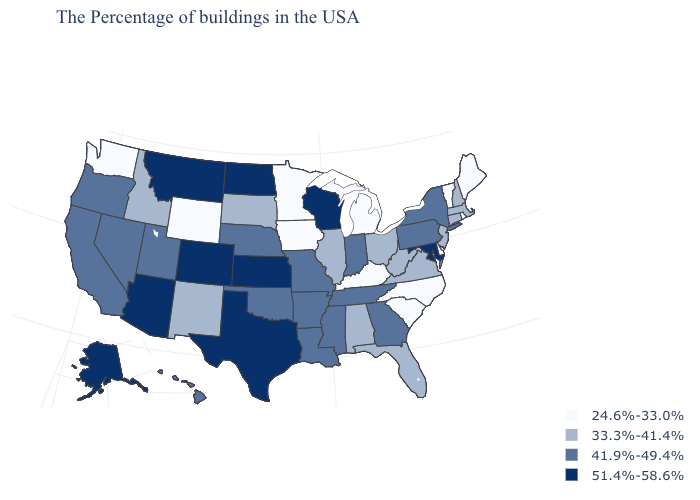Which states hav the highest value in the West?
Write a very short answer. Colorado, Montana, Arizona, Alaska. What is the value of Minnesota?
Answer briefly. 24.6%-33.0%. Does Missouri have a lower value than North Dakota?
Give a very brief answer. Yes. Which states have the highest value in the USA?
Answer briefly. Maryland, Wisconsin, Kansas, Texas, North Dakota, Colorado, Montana, Arizona, Alaska. Does Massachusetts have the lowest value in the Northeast?
Quick response, please. No. Does Vermont have the lowest value in the Northeast?
Short answer required. Yes. What is the value of Wisconsin?
Keep it brief. 51.4%-58.6%. Among the states that border Michigan , does Wisconsin have the highest value?
Keep it brief. Yes. What is the value of Kentucky?
Give a very brief answer. 24.6%-33.0%. What is the value of Alaska?
Quick response, please. 51.4%-58.6%. Name the states that have a value in the range 24.6%-33.0%?
Be succinct. Maine, Rhode Island, Vermont, Delaware, North Carolina, South Carolina, Michigan, Kentucky, Minnesota, Iowa, Wyoming, Washington. Does Texas have the highest value in the USA?
Keep it brief. Yes. Does Connecticut have the lowest value in the USA?
Keep it brief. No. Name the states that have a value in the range 41.9%-49.4%?
Concise answer only. New York, Pennsylvania, Georgia, Indiana, Tennessee, Mississippi, Louisiana, Missouri, Arkansas, Nebraska, Oklahoma, Utah, Nevada, California, Oregon, Hawaii. Name the states that have a value in the range 41.9%-49.4%?
Be succinct. New York, Pennsylvania, Georgia, Indiana, Tennessee, Mississippi, Louisiana, Missouri, Arkansas, Nebraska, Oklahoma, Utah, Nevada, California, Oregon, Hawaii. 